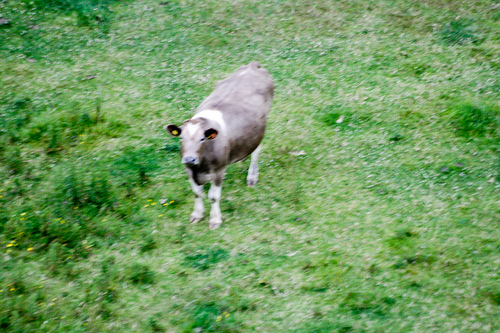<image>
Is the cow behind the grass? No. The cow is not behind the grass. From this viewpoint, the cow appears to be positioned elsewhere in the scene. Is the grass on the cow? No. The grass is not positioned on the cow. They may be near each other, but the grass is not supported by or resting on top of the cow. Is there a cow to the left of the plant? No. The cow is not to the left of the plant. From this viewpoint, they have a different horizontal relationship. 